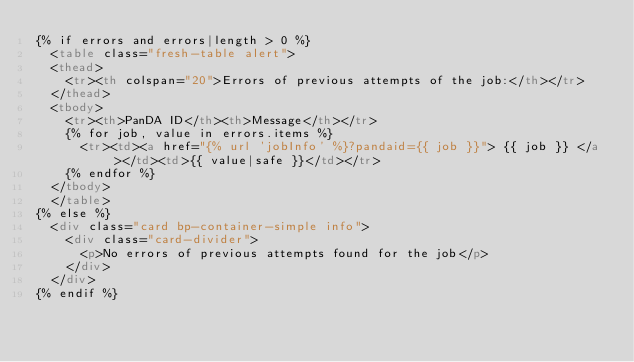<code> <loc_0><loc_0><loc_500><loc_500><_HTML_>{% if errors and errors|length > 0 %}
  <table class="fresh-table alert">
  <thead>
    <tr><th colspan="20">Errors of previous attempts of the job:</th></tr>
  </thead>
  <tbody>
    <tr><th>PanDA ID</th><th>Message</th></tr>
    {% for job, value in errors.items %}
      <tr><td><a href="{% url 'jobInfo' %}?pandaid={{ job }}"> {{ job }} </a></td><td>{{ value|safe }}</td></tr>
    {% endfor %}
  </tbody>
  </table>
{% else %}
  <div class="card bp-container-simple info">
    <div class="card-divider">
      <p>No errors of previous attempts found for the job</p>
    </div>
  </div>
{% endif %}
</code> 